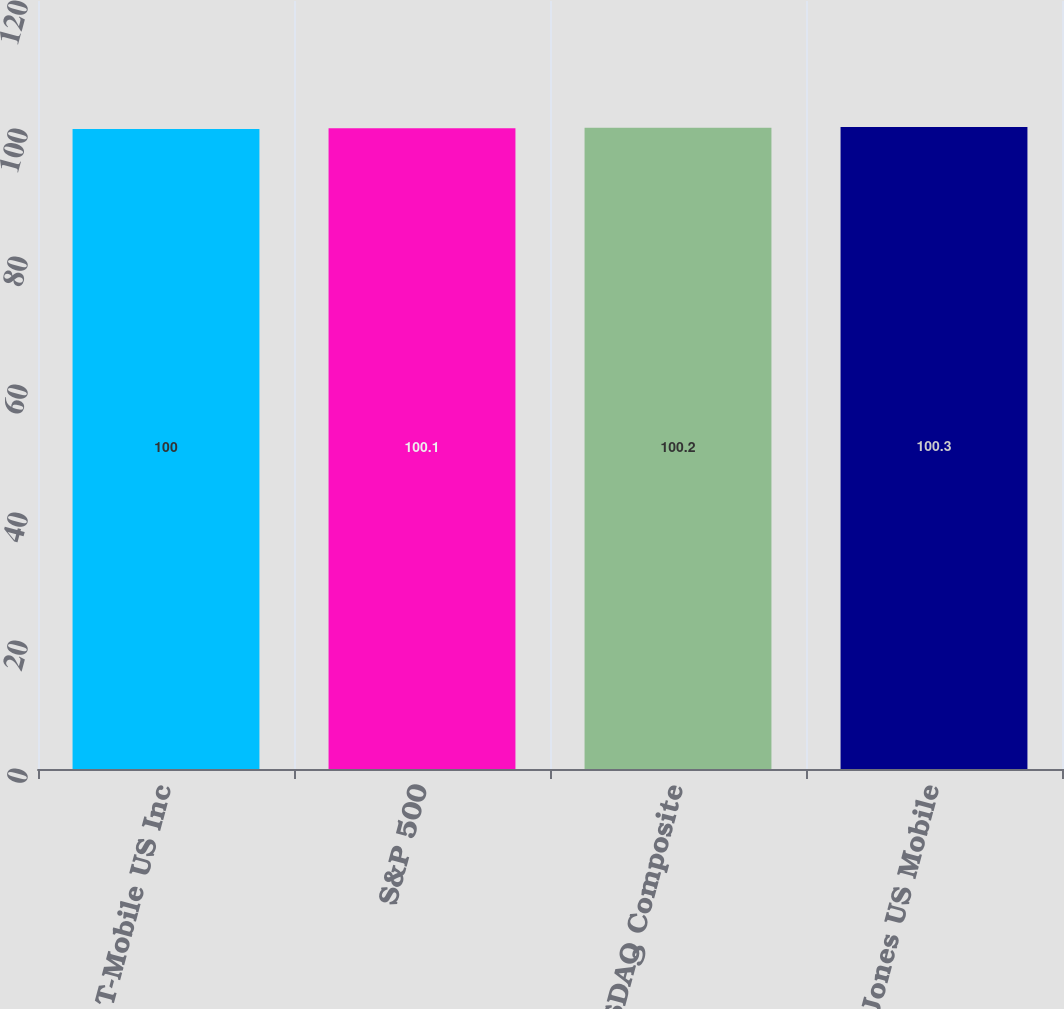<chart> <loc_0><loc_0><loc_500><loc_500><bar_chart><fcel>T-Mobile US Inc<fcel>S&P 500<fcel>NASDAQ Composite<fcel>Dow Jones US Mobile<nl><fcel>100<fcel>100.1<fcel>100.2<fcel>100.3<nl></chart> 